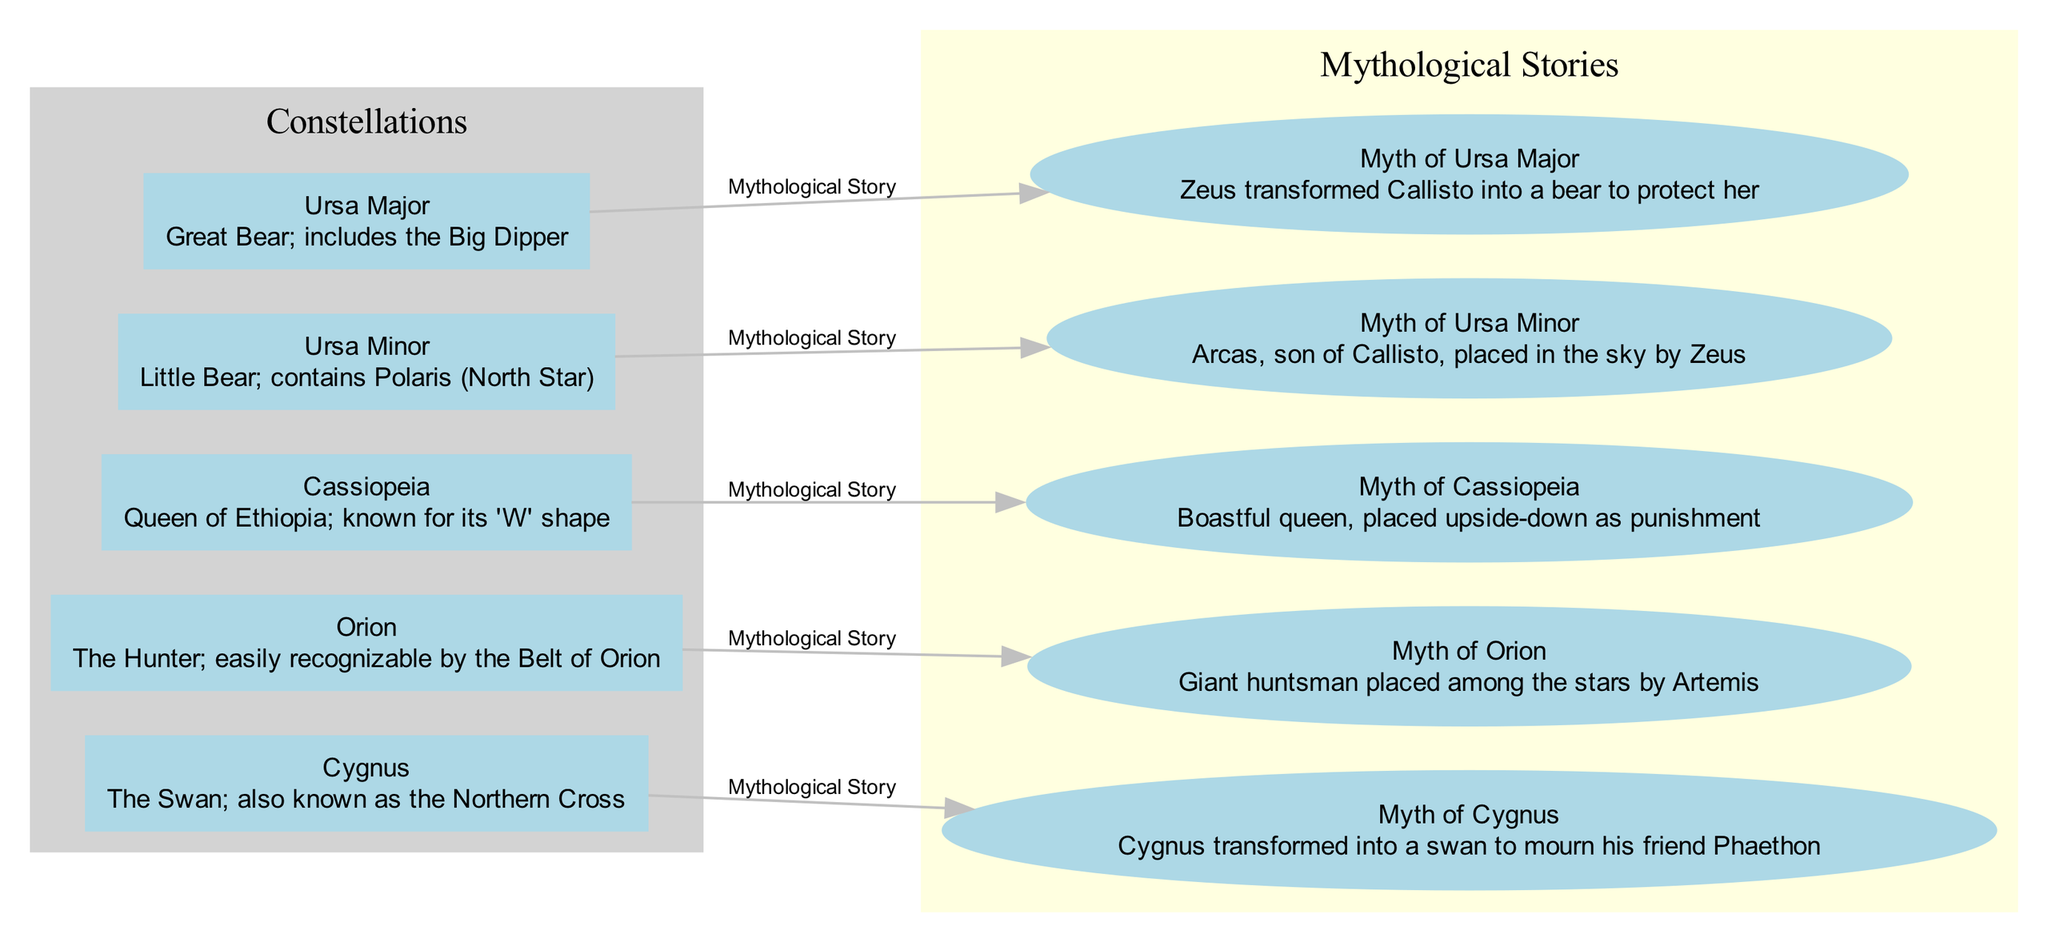What is the label of node 1? Node 1 is labeled as "Ursa Major." The diagram identifies this node as one of the constellations.
Answer: Ursa Major How many constellations are displayed in the diagram? The diagram shows five constellations, each represented by their own node. This can be counted directly from the nodes section of the diagram.
Answer: 5 Which constellation is associated with the myth of Callisto? The constellation Ursa Major is linked to the myth of Callisto, as indicated by the edge connecting the two in the diagram.
Answer: Ursa Major What shape does the constellation Cassiopeia resemble? The constellation Cassiopeia is known for its 'W' shape, as described in its node. This description directly answers the question regarding its visual appearance.
Answer: 'W' Which mythological story involves Artemis? The myth associated with Orion involves Artemis as she placed the giant huntsman among the stars. This is found in the connection between the constellation Orion and its mythological story in the diagram.
Answer: Myth of Orion In what shape is the constellation Cygnus known? Cygnus is also known as the Northern Cross; the node for Cygnus contains this descriptive information, directly addressing the question.
Answer: Northern Cross What punishment did Cassiopeia receive according to the legend? Cassiopeia was placed upside-down as punishment for her boastfulness, as described in the corresponding myth node in the diagram.
Answer: Upside-down Which constellation contains the North Star? Ursa Minor is the constellation that contains Polaris, also known as the North Star, highlighted in its description in the diagram.
Answer: Ursa Minor What transformation is depicted in the myth of Cygnus? The myth of Cygnus involves his transformation into a swan, as stated directly in the description of the myth node linked to the constellation Cygnus.
Answer: Transformed into a swan 